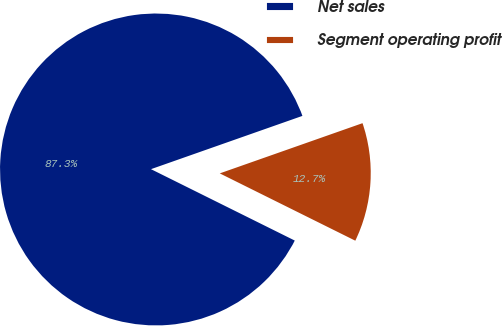Convert chart to OTSL. <chart><loc_0><loc_0><loc_500><loc_500><pie_chart><fcel>Net sales<fcel>Segment operating profit<nl><fcel>87.28%<fcel>12.72%<nl></chart> 